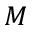Convert formula to latex. <formula><loc_0><loc_0><loc_500><loc_500>M</formula> 